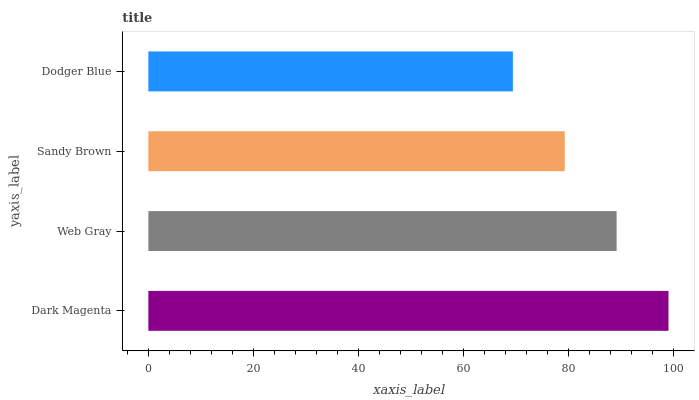Is Dodger Blue the minimum?
Answer yes or no. Yes. Is Dark Magenta the maximum?
Answer yes or no. Yes. Is Web Gray the minimum?
Answer yes or no. No. Is Web Gray the maximum?
Answer yes or no. No. Is Dark Magenta greater than Web Gray?
Answer yes or no. Yes. Is Web Gray less than Dark Magenta?
Answer yes or no. Yes. Is Web Gray greater than Dark Magenta?
Answer yes or no. No. Is Dark Magenta less than Web Gray?
Answer yes or no. No. Is Web Gray the high median?
Answer yes or no. Yes. Is Sandy Brown the low median?
Answer yes or no. Yes. Is Dodger Blue the high median?
Answer yes or no. No. Is Dodger Blue the low median?
Answer yes or no. No. 